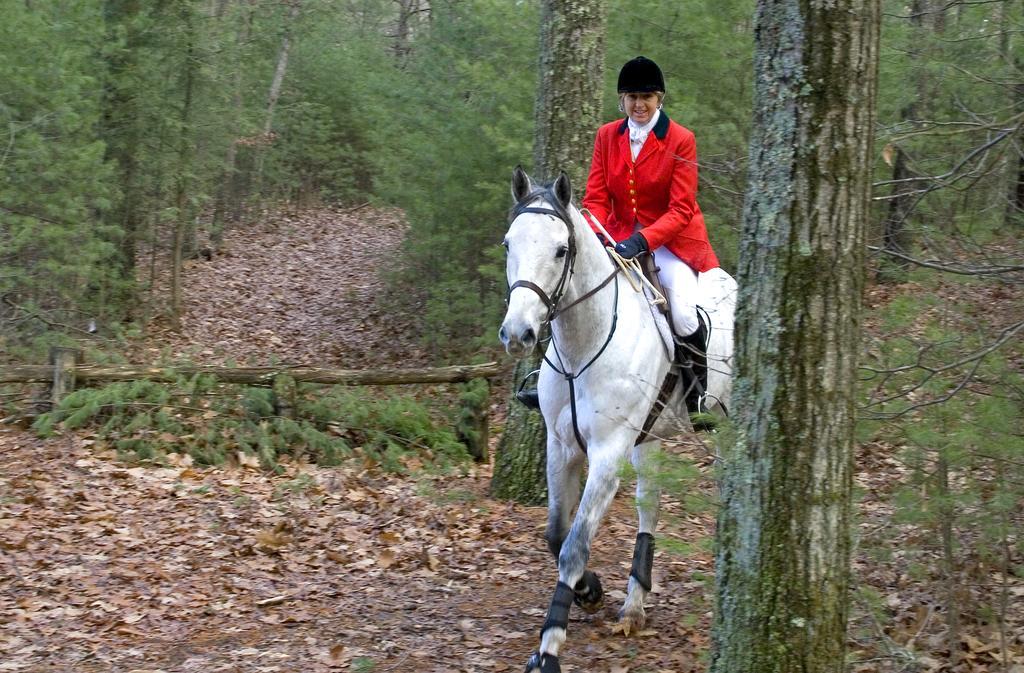How would you summarize this image in a sentence or two? In this image in the center there is one person who is sitting on a horse and riding, and in the background there are some trees and some dry leaves. 